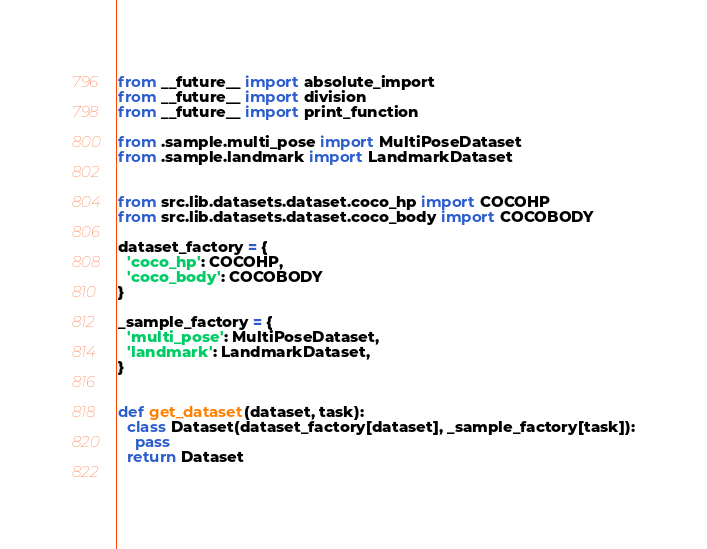Convert code to text. <code><loc_0><loc_0><loc_500><loc_500><_Python_>from __future__ import absolute_import
from __future__ import division
from __future__ import print_function

from .sample.multi_pose import MultiPoseDataset
from .sample.landmark import LandmarkDataset


from src.lib.datasets.dataset.coco_hp import COCOHP
from src.lib.datasets.dataset.coco_body import COCOBODY

dataset_factory = {
  'coco_hp': COCOHP,
  'coco_body': COCOBODY
}

_sample_factory = {
  'multi_pose': MultiPoseDataset,
  'landmark': LandmarkDataset,
}


def get_dataset(dataset, task):
  class Dataset(dataset_factory[dataset], _sample_factory[task]):
    pass
  return Dataset
  
</code> 